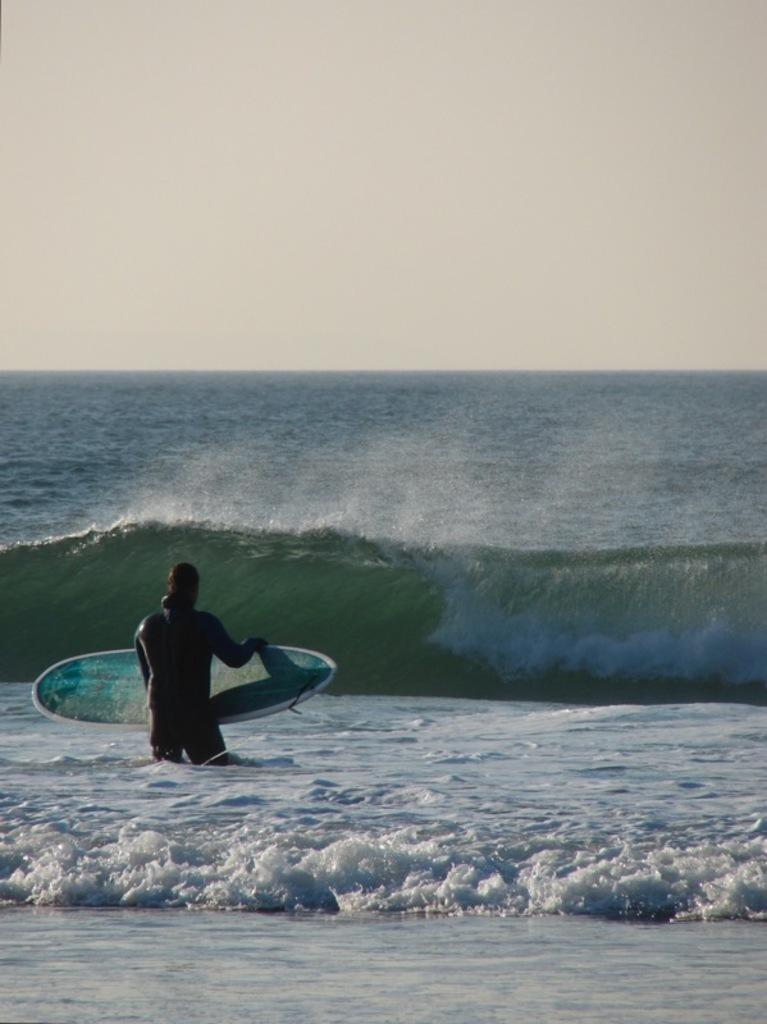Who is present in the image? There is a man in the image. What is the man holding in the image? The man is holding a surfboard. What can be seen in the background of the image? There is water and the sky visible in the background of the image. What type of fiction is the man reading while surfing in the image? There is no indication in the image that the man is reading any fiction; he is holding a surfboard and there is water and sky visible in the background. 